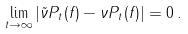Convert formula to latex. <formula><loc_0><loc_0><loc_500><loc_500>\lim _ { t \to \infty } | \tilde { \nu } P _ { t } ( f ) - \nu P _ { t } ( f ) | = 0 \, .</formula> 